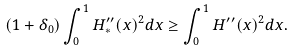<formula> <loc_0><loc_0><loc_500><loc_500>( 1 + \delta _ { 0 } ) \int _ { 0 } ^ { 1 } H _ { * } ^ { \prime \prime } ( x ) ^ { 2 } d x \geq \int _ { 0 } ^ { 1 } H ^ { \prime \prime } ( x ) ^ { 2 } d x .</formula> 